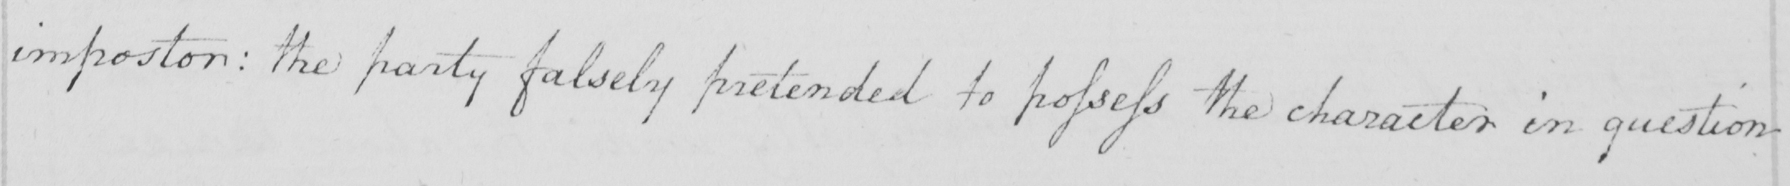Transcribe the text shown in this historical manuscript line. impostor :  the party falsely pretended to possess the character in question 